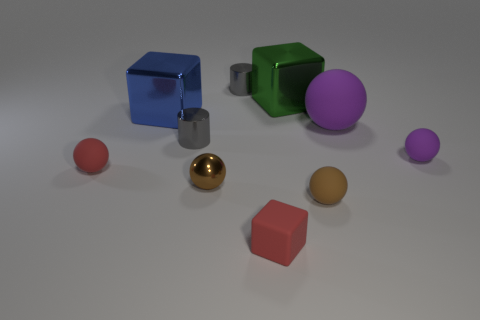There is a matte sphere that is the same color as the tiny cube; what size is it?
Your answer should be compact. Small. There is a big thing that is both right of the blue block and in front of the green metal block; what is its shape?
Provide a succinct answer. Sphere. What number of other objects are there of the same shape as the brown metal thing?
Your response must be concise. 4. What is the size of the blue object?
Offer a very short reply. Large. How many things are large green metallic cylinders or small red cubes?
Provide a short and direct response. 1. There is a brown ball that is to the right of the small block; how big is it?
Ensure brevity in your answer.  Small. Is there any other thing that has the same size as the brown matte object?
Give a very brief answer. Yes. What is the color of the thing that is behind the blue shiny cube and to the right of the matte block?
Your answer should be compact. Green. Do the gray thing in front of the blue metal object and the tiny red ball have the same material?
Your answer should be very brief. No. There is a small matte cube; is its color the same as the small matte thing to the left of the big blue shiny object?
Your answer should be very brief. Yes. 